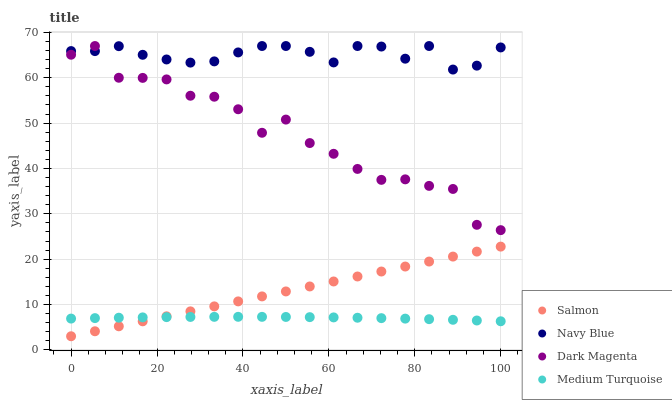Does Medium Turquoise have the minimum area under the curve?
Answer yes or no. Yes. Does Navy Blue have the maximum area under the curve?
Answer yes or no. Yes. Does Salmon have the minimum area under the curve?
Answer yes or no. No. Does Salmon have the maximum area under the curve?
Answer yes or no. No. Is Salmon the smoothest?
Answer yes or no. Yes. Is Dark Magenta the roughest?
Answer yes or no. Yes. Is Dark Magenta the smoothest?
Answer yes or no. No. Is Salmon the roughest?
Answer yes or no. No. Does Salmon have the lowest value?
Answer yes or no. Yes. Does Dark Magenta have the lowest value?
Answer yes or no. No. Does Dark Magenta have the highest value?
Answer yes or no. Yes. Does Salmon have the highest value?
Answer yes or no. No. Is Medium Turquoise less than Dark Magenta?
Answer yes or no. Yes. Is Dark Magenta greater than Medium Turquoise?
Answer yes or no. Yes. Does Medium Turquoise intersect Salmon?
Answer yes or no. Yes. Is Medium Turquoise less than Salmon?
Answer yes or no. No. Is Medium Turquoise greater than Salmon?
Answer yes or no. No. Does Medium Turquoise intersect Dark Magenta?
Answer yes or no. No. 